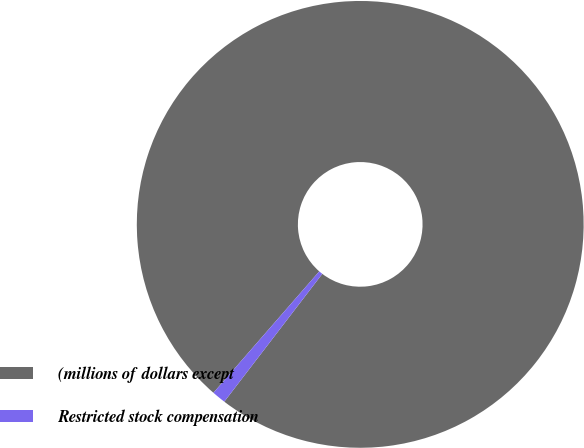Convert chart to OTSL. <chart><loc_0><loc_0><loc_500><loc_500><pie_chart><fcel>(millions of dollars except<fcel>Restricted stock compensation<nl><fcel>99.0%<fcel>1.0%<nl></chart> 